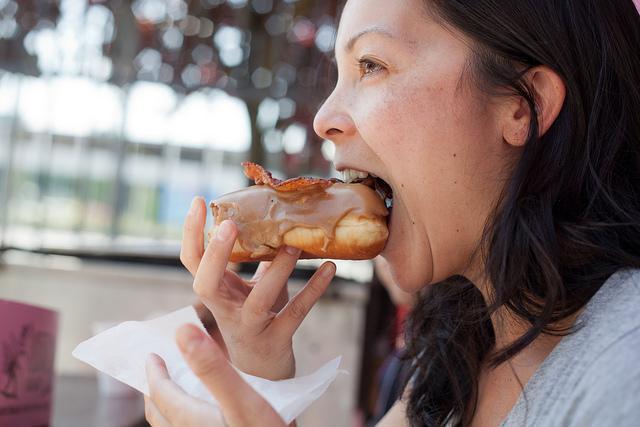How many different types of cakes are there?
Give a very brief answer. 0. 